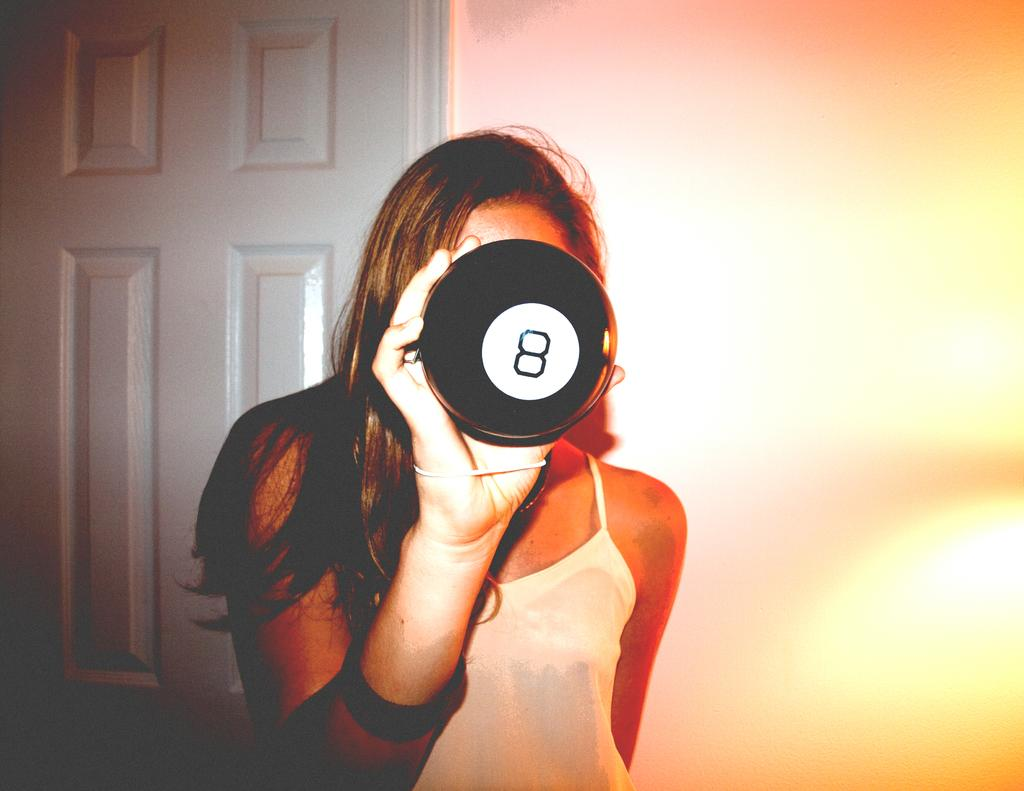Who is present in the image? There is a woman in the image. What is the woman doing in the image? The woman is standing in the image. What is the woman holding in her hand? The woman is holding an object in her hand. What can be seen in the background of the image? There is a white color door and a wall in the background of the image. What type of wood is the rose made of in the image? There is no rose present in the image, so it is not possible to determine what type of wood it might be made of. 